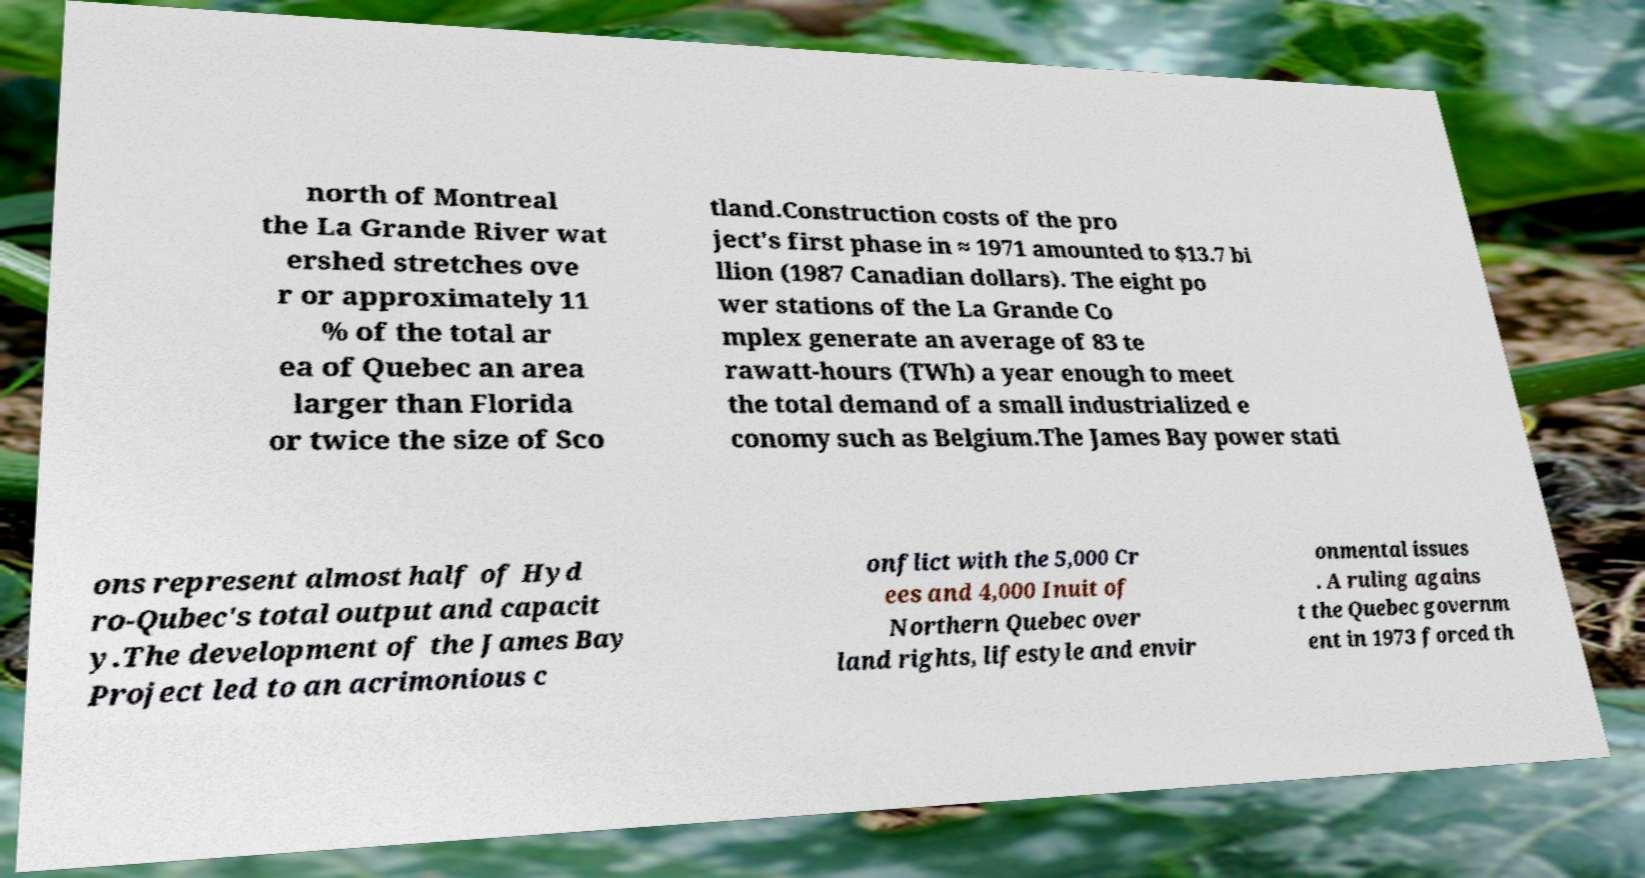Could you extract and type out the text from this image? north of Montreal the La Grande River wat ershed stretches ove r or approximately 11 % of the total ar ea of Quebec an area larger than Florida or twice the size of Sco tland.Construction costs of the pro ject's first phase in ≈ 1971 amounted to $13.7 bi llion (1987 Canadian dollars). The eight po wer stations of the La Grande Co mplex generate an average of 83 te rawatt-hours (TWh) a year enough to meet the total demand of a small industrialized e conomy such as Belgium.The James Bay power stati ons represent almost half of Hyd ro-Qubec's total output and capacit y.The development of the James Bay Project led to an acrimonious c onflict with the 5,000 Cr ees and 4,000 Inuit of Northern Quebec over land rights, lifestyle and envir onmental issues . A ruling agains t the Quebec governm ent in 1973 forced th 